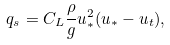Convert formula to latex. <formula><loc_0><loc_0><loc_500><loc_500>q _ { s } = C _ { L } \frac { \rho } { g } u _ { * } ^ { 2 } ( u _ { * } - u _ { t } ) ,</formula> 